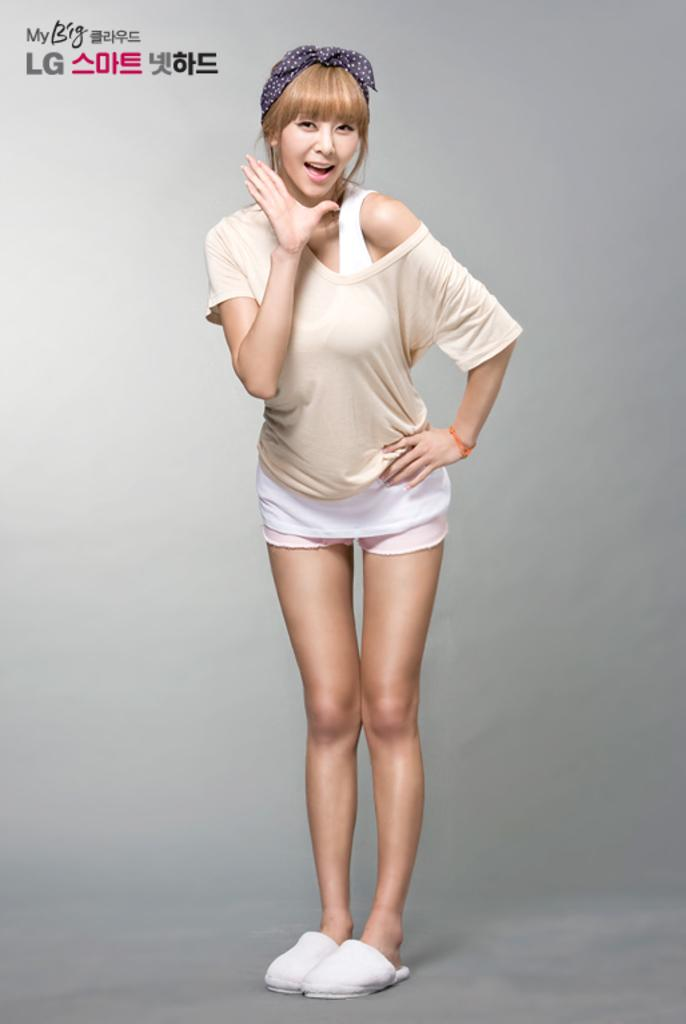Who is the main subject in the image? There is a woman in the center of the image. What is written or displayed at the top of the image? There is text at the top of the image. What can be seen in the background of the image? There is a wall in the background of the image. What type of bear can be seen interacting with the woman in the image? There is no bear present in the image; it only features a woman, text, and a wall in the background. 